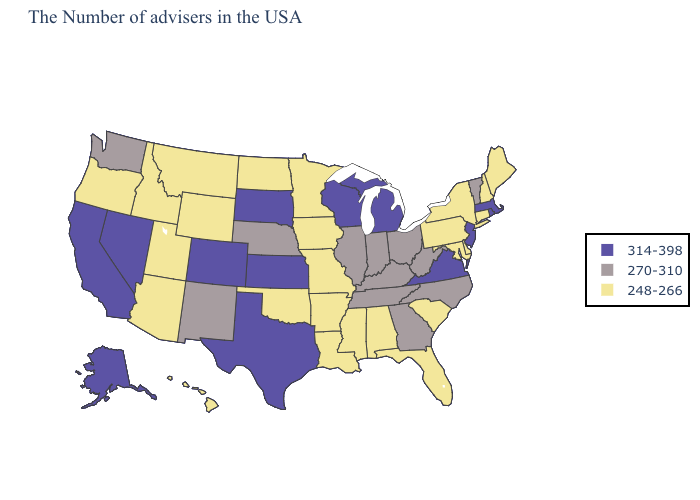Name the states that have a value in the range 270-310?
Quick response, please. Vermont, North Carolina, West Virginia, Ohio, Georgia, Kentucky, Indiana, Tennessee, Illinois, Nebraska, New Mexico, Washington. Which states hav the highest value in the Northeast?
Keep it brief. Massachusetts, Rhode Island, New Jersey. Among the states that border Oregon , which have the lowest value?
Quick response, please. Idaho. Name the states that have a value in the range 270-310?
Keep it brief. Vermont, North Carolina, West Virginia, Ohio, Georgia, Kentucky, Indiana, Tennessee, Illinois, Nebraska, New Mexico, Washington. Among the states that border Oregon , does Idaho have the highest value?
Answer briefly. No. Does North Dakota have the highest value in the USA?
Keep it brief. No. Does Tennessee have a higher value than Illinois?
Keep it brief. No. Among the states that border New Mexico , does Utah have the highest value?
Concise answer only. No. Name the states that have a value in the range 270-310?
Answer briefly. Vermont, North Carolina, West Virginia, Ohio, Georgia, Kentucky, Indiana, Tennessee, Illinois, Nebraska, New Mexico, Washington. Name the states that have a value in the range 270-310?
Answer briefly. Vermont, North Carolina, West Virginia, Ohio, Georgia, Kentucky, Indiana, Tennessee, Illinois, Nebraska, New Mexico, Washington. What is the value of Pennsylvania?
Write a very short answer. 248-266. Which states hav the highest value in the Northeast?
Be succinct. Massachusetts, Rhode Island, New Jersey. Which states have the lowest value in the USA?
Answer briefly. Maine, New Hampshire, Connecticut, New York, Delaware, Maryland, Pennsylvania, South Carolina, Florida, Alabama, Mississippi, Louisiana, Missouri, Arkansas, Minnesota, Iowa, Oklahoma, North Dakota, Wyoming, Utah, Montana, Arizona, Idaho, Oregon, Hawaii. Among the states that border Pennsylvania , which have the lowest value?
Be succinct. New York, Delaware, Maryland. What is the lowest value in states that border North Dakota?
Short answer required. 248-266. 